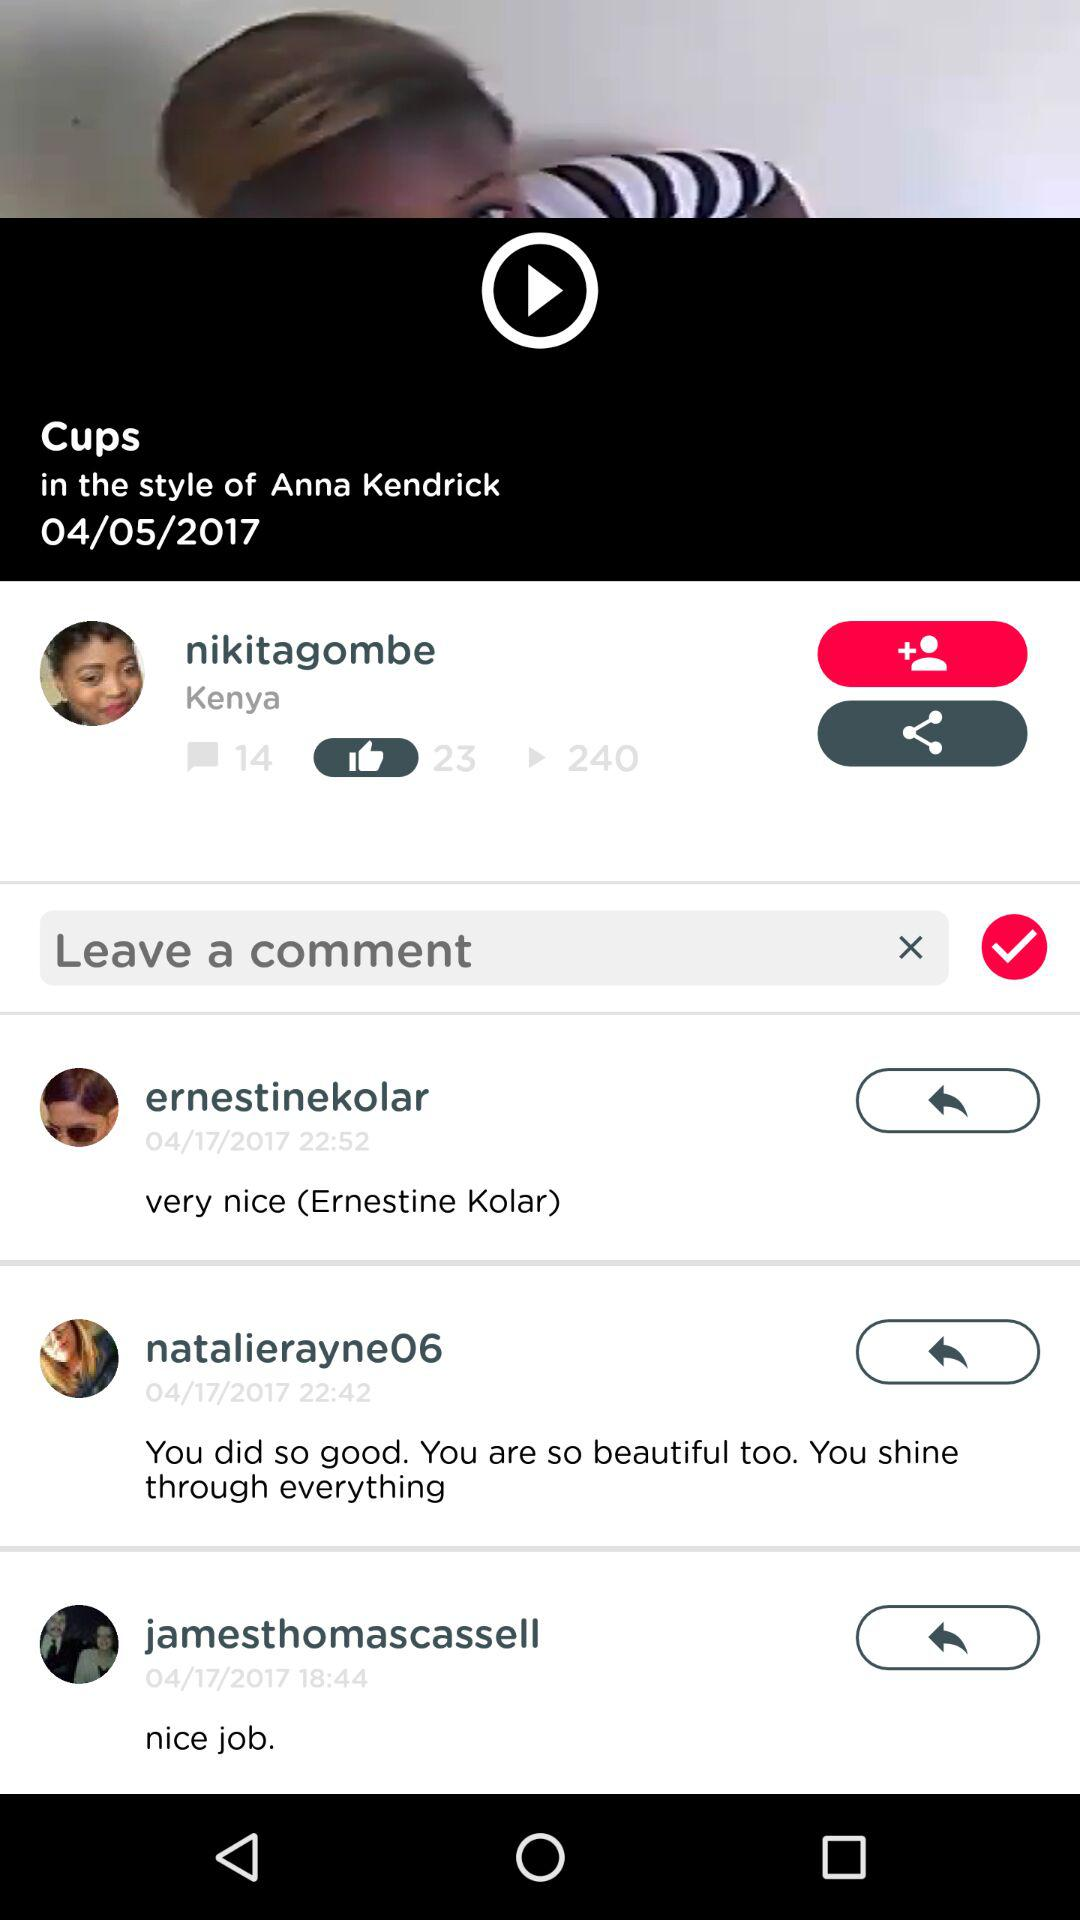What is the posting date for the video? The posting date for the video is April 5, 2017. 